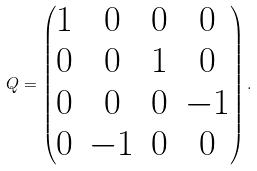Convert formula to latex. <formula><loc_0><loc_0><loc_500><loc_500>Q = \begin{pmatrix} 1 & 0 & 0 & 0 \\ 0 & 0 & 1 & 0 \\ 0 & 0 & 0 & - 1 \\ 0 & - 1 & 0 & 0 \end{pmatrix} .</formula> 